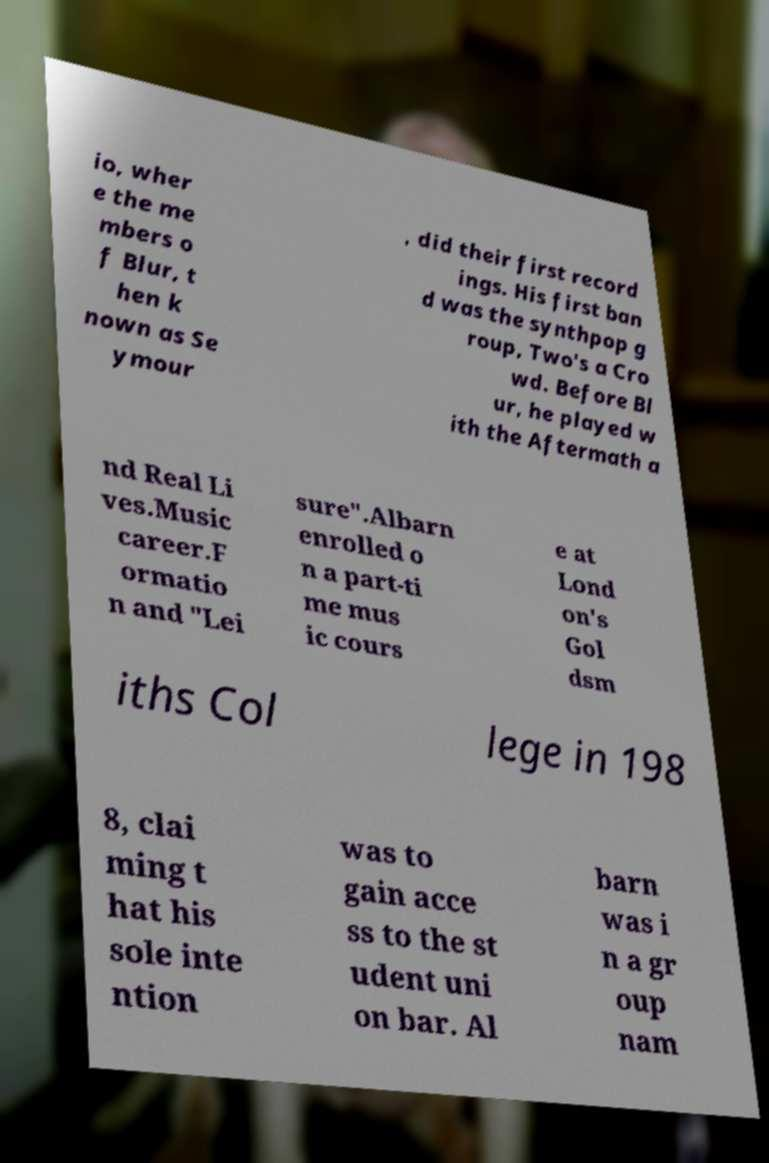Can you accurately transcribe the text from the provided image for me? io, wher e the me mbers o f Blur, t hen k nown as Se ymour , did their first record ings. His first ban d was the synthpop g roup, Two's a Cro wd. Before Bl ur, he played w ith the Aftermath a nd Real Li ves.Music career.F ormatio n and "Lei sure".Albarn enrolled o n a part-ti me mus ic cours e at Lond on's Gol dsm iths Col lege in 198 8, clai ming t hat his sole inte ntion was to gain acce ss to the st udent uni on bar. Al barn was i n a gr oup nam 